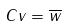<formula> <loc_0><loc_0><loc_500><loc_500>C v = \overline { w }</formula> 